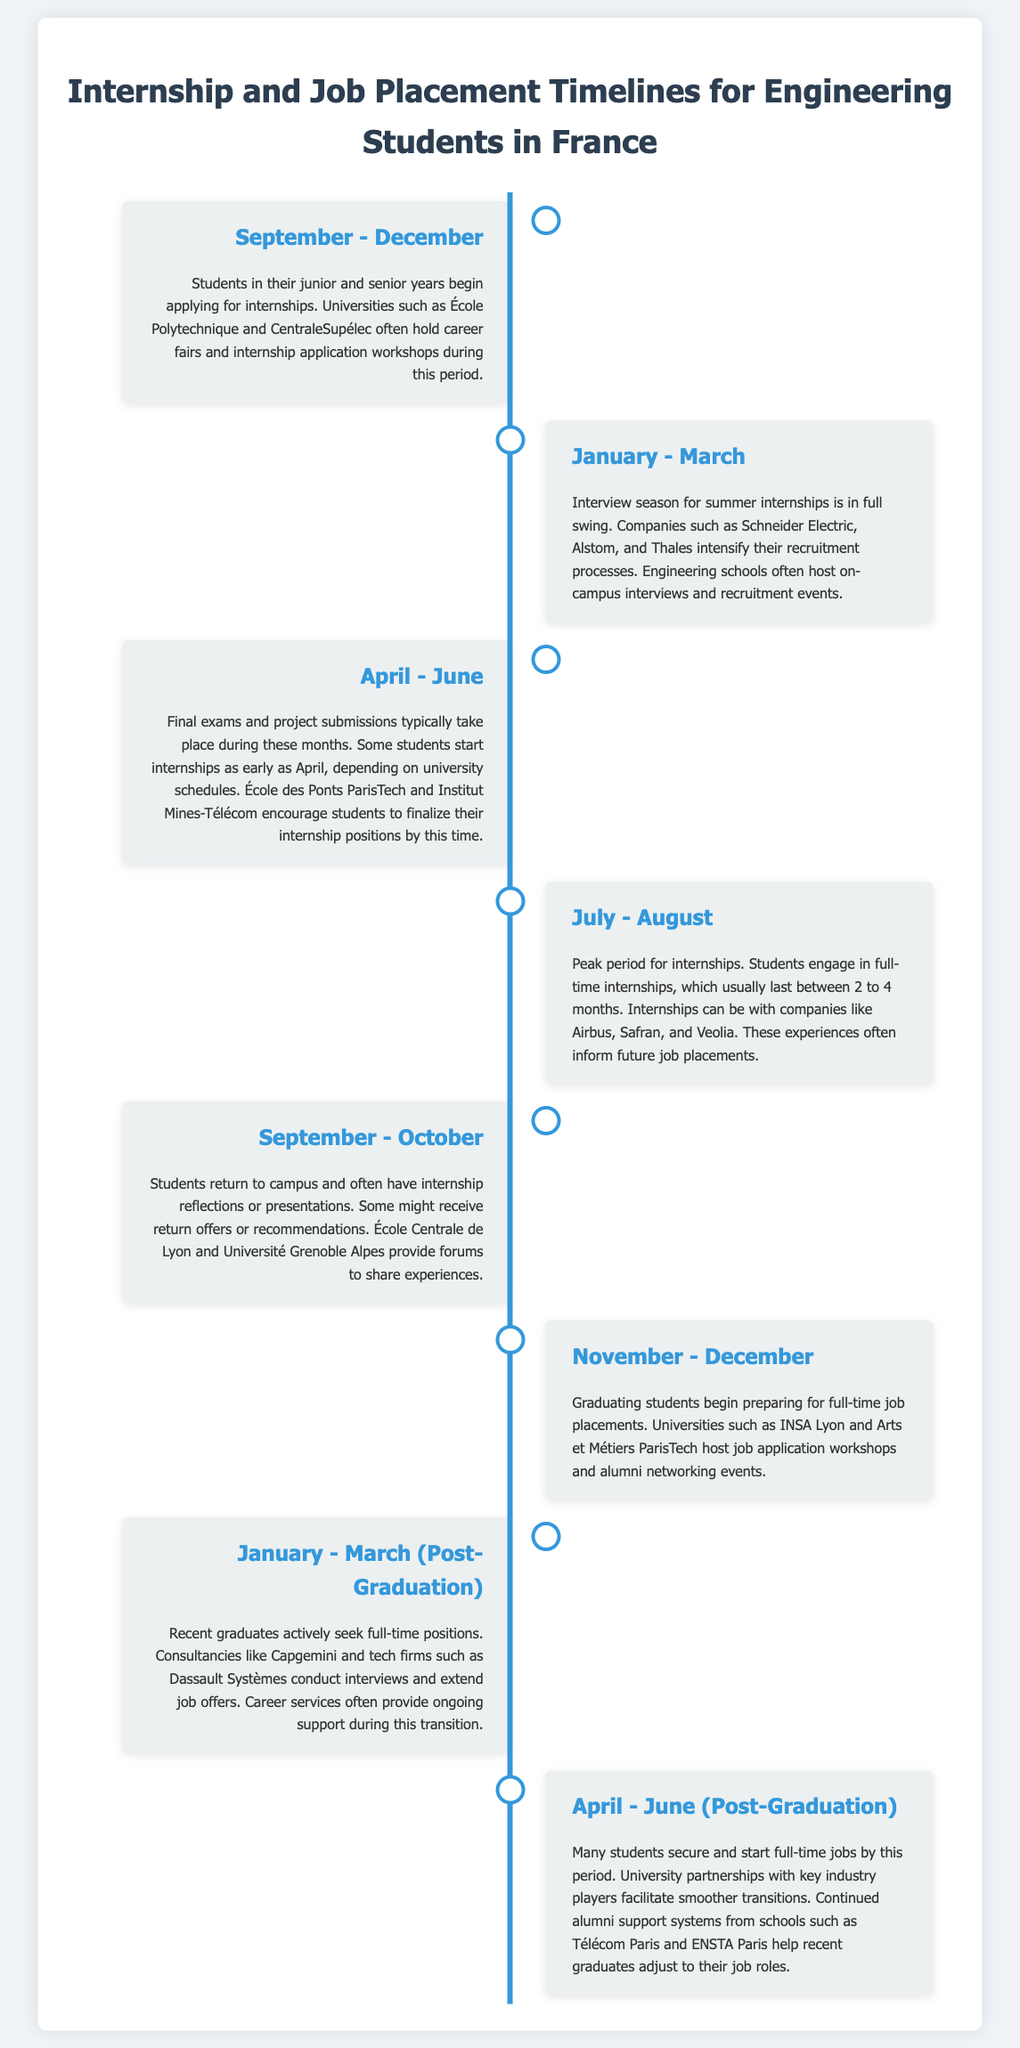What is the typical period for applying for internships? The document states that students begin applying for internships from September to December.
Answer: September - December Which companies intensify recruitment for summer internships? Companies like Schneider Electric, Alstom, and Thales have intensified recruitment during January to March.
Answer: Schneider Electric, Alstom, Thales What months are characterized by full-time internship placement? The peak period for internships is described to be from July to August.
Answer: July - August When do students typically prepare for job placements? Graduating students start preparing for full-time job placements during November to December.
Answer: November - December What is the timeframe when recent graduates actively seek positions? The document indicates that recent graduates actively seek full-time positions from January to March.
Answer: January - March How long do internships typically last? The document specifies that internships usually last between 2 to 4 months.
Answer: 2 to 4 months During which months do students receive return offers or recommendations? The document mentions that this occurs in September to October.
Answer: September - October Which university hosts job application workshops for graduating students? INSA Lyon is mentioned as hosting job application workshops during November to December.
Answer: INSA Lyon 